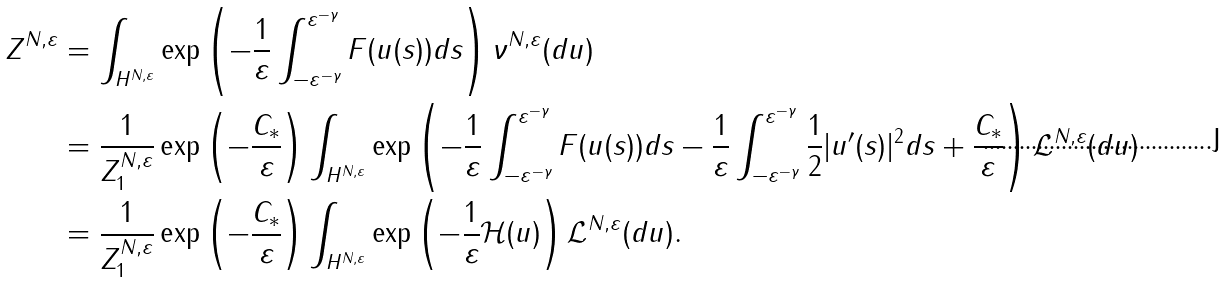<formula> <loc_0><loc_0><loc_500><loc_500>Z ^ { N , \varepsilon } & = \int _ { H ^ { N , \varepsilon } } \exp \left ( - \frac { 1 } { \varepsilon } \int _ { - \varepsilon ^ { - \gamma } } ^ { \varepsilon ^ { - \gamma } } F ( u ( s ) ) d s \right ) \nu ^ { N , \varepsilon } ( d u ) \\ & = \frac { 1 } { Z ^ { N , \varepsilon } _ { 1 } } \exp \left ( - \frac { C _ { * } } { \varepsilon } \right ) \int _ { H ^ { N , \varepsilon } } \exp \left ( - \frac { 1 } { \varepsilon } \int _ { - \varepsilon ^ { - \gamma } } ^ { \varepsilon ^ { - \gamma } } F ( u ( s ) ) d s - \frac { 1 } { \varepsilon } \int _ { - \varepsilon ^ { - \gamma } } ^ { \varepsilon ^ { - \gamma } } \frac { 1 } { 2 } | u ^ { \prime } ( s ) | ^ { 2 } d s + \frac { C _ { * } } { \varepsilon } \right ) \mathcal { L } ^ { N , \varepsilon } ( d u ) \\ & = \frac { 1 } { Z ^ { N , \varepsilon } _ { 1 } } \exp \left ( - \frac { C _ { * } } { \varepsilon } \right ) \int _ { H ^ { N , \varepsilon } } \exp \left ( - \frac { 1 } { \varepsilon } \mathcal { H } ( u ) \right ) \mathcal { L } ^ { N , \varepsilon } ( d u ) .</formula> 